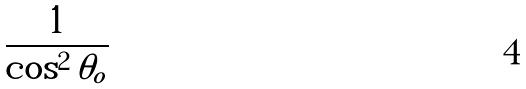<formula> <loc_0><loc_0><loc_500><loc_500>\frac { 1 } { \cos ^ { 2 } \theta _ { o } }</formula> 